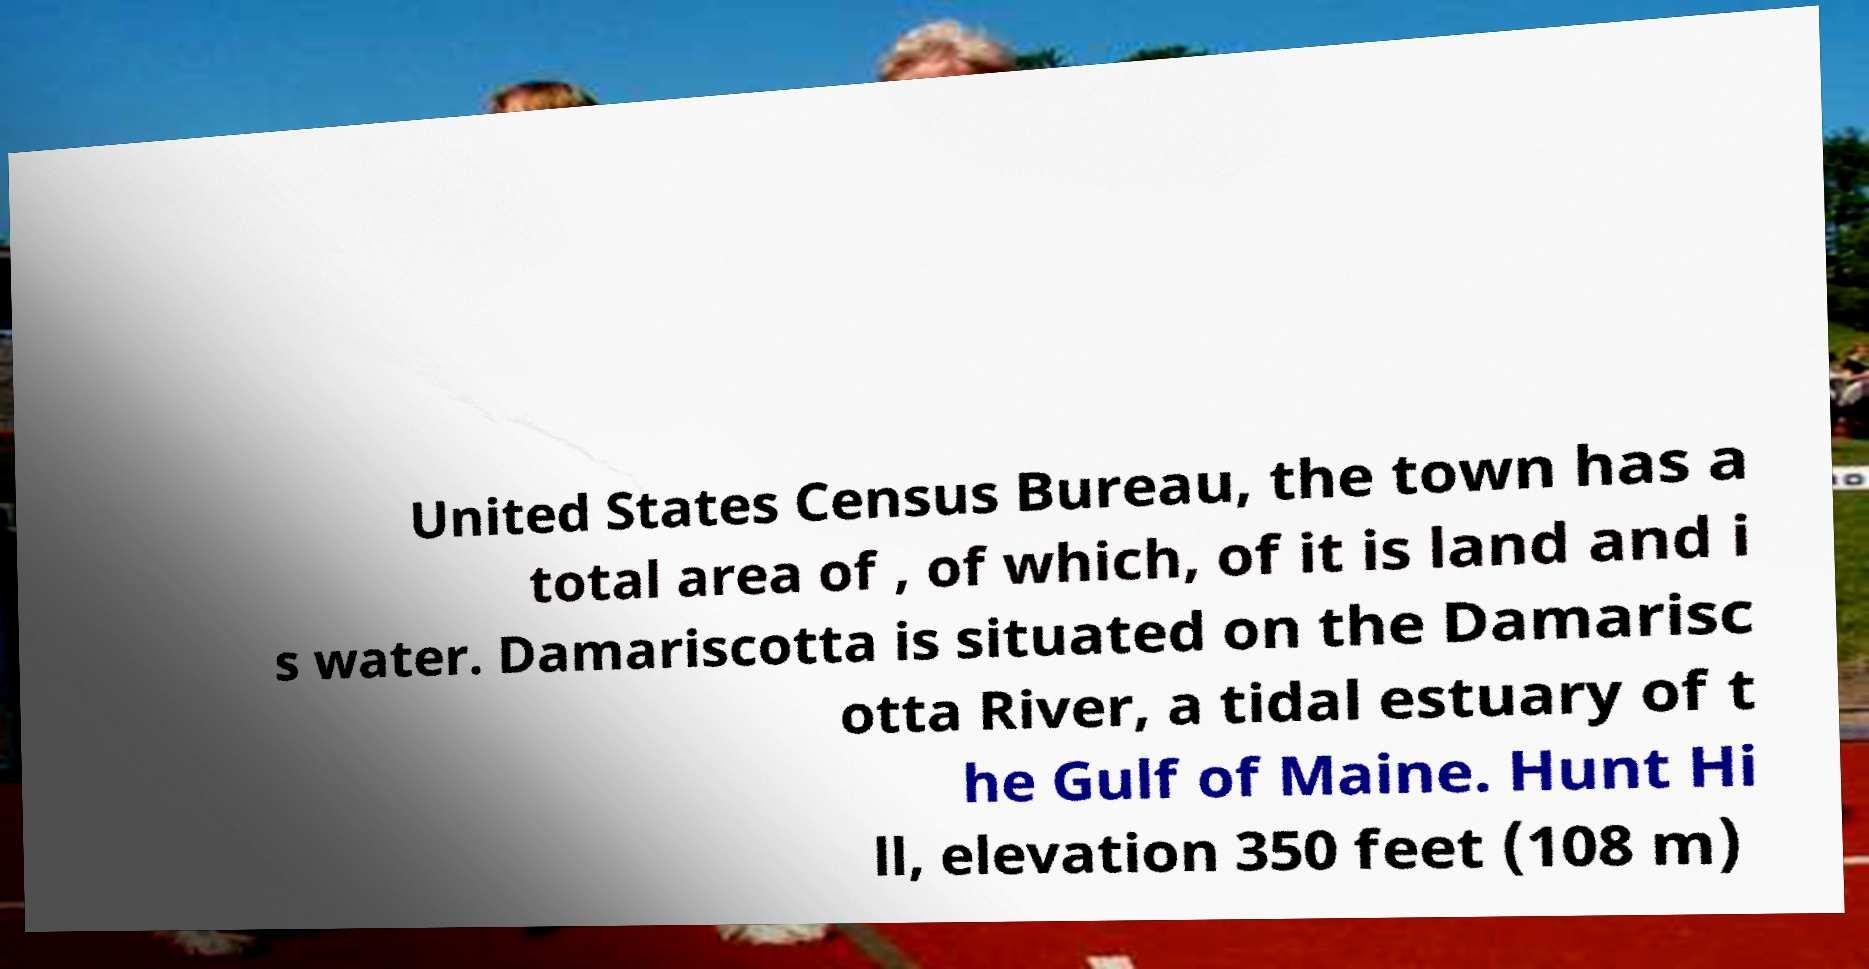Can you read and provide the text displayed in the image?This photo seems to have some interesting text. Can you extract and type it out for me? United States Census Bureau, the town has a total area of , of which, of it is land and i s water. Damariscotta is situated on the Damarisc otta River, a tidal estuary of t he Gulf of Maine. Hunt Hi ll, elevation 350 feet (108 m) 